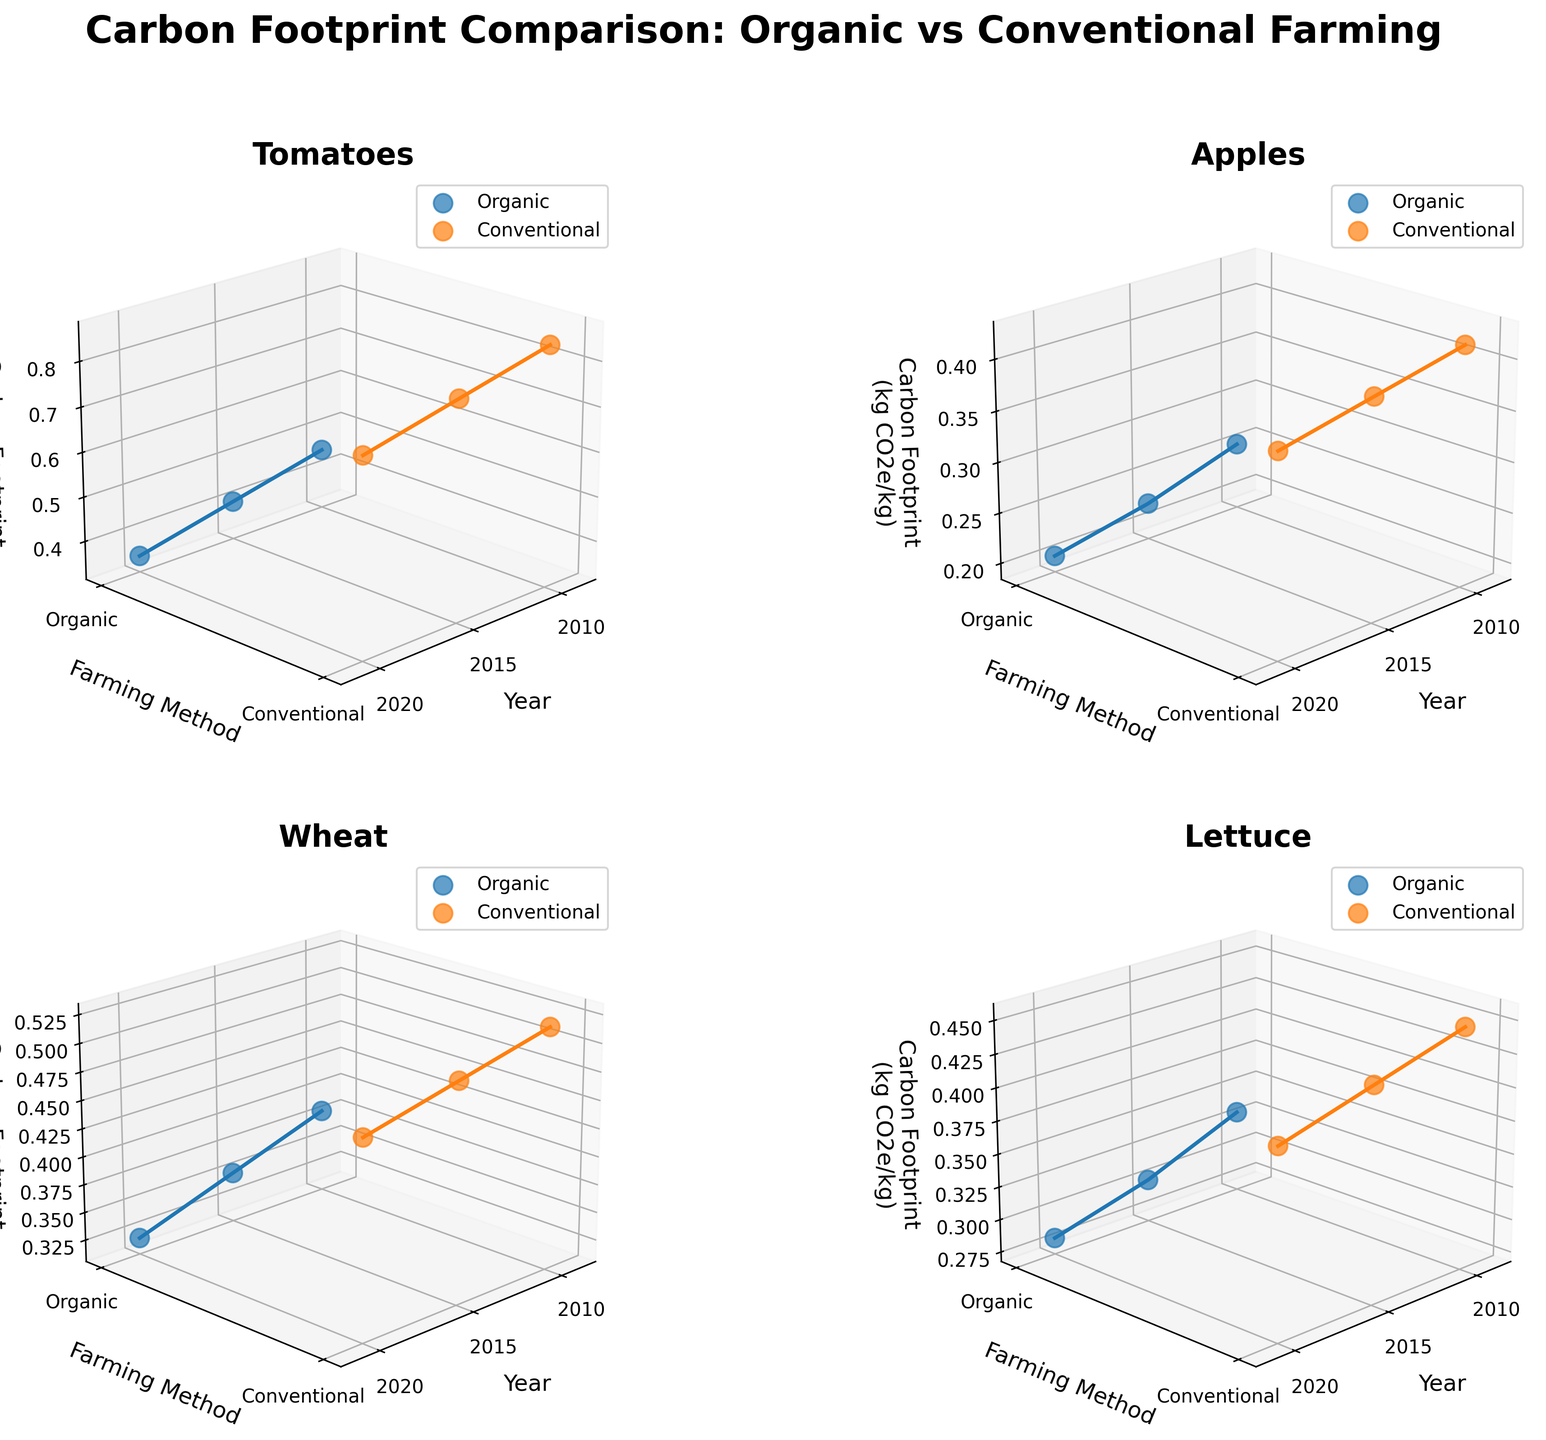What is the title of the figure? The title of the figure is shown at the top of the plot. It's written text within the figure.
Answer: Carbon Footprint Comparison: Organic vs Conventional Farming How many products are compared in the figure? To find the number of products, examine the subplots in the figure. Each subplot corresponds to a different product. Count the subplots to determine the number of products compared.
Answer: 4 Which farming method has a higher carbon footprint for Tomatoes in 2020? Look at the subplot for Tomatoes and compare the height of the points (z-axis value) at the year 2020 for both farming methods (Organic and Conventional).
Answer: Conventional What is the trend for the carbon footprint of Organic Apples from 2010 to 2020? Examine the subplot for Apples and look at the points corresponding to Organic farming from 2010 to 2020. Note the change in the height of these points (z-axis values) over time.
Answer: Decreasing Compare the carbon footprint of Organic and Conventional Wheat in 2010 and 2020. Which year and farming method combination has the lowest carbon footprint? Look at the subplot for Wheat and compare the z-axis values for Organic and Conventional farming methods in both 2010 and 2020. Identify the combination with the smallest value.
Answer: Organic Wheat in 2020 Which farming method has a greater reduction in carbon footprint for Lettuce between 2010 and 2020? Examine the subplot for Lettuce and calculate the difference in z-axis values from 2010 to 2020 for both Organic and Conventional farming methods. Compare these reductions.
Answer: Organic What's the average carbon footprint for Conventional Tomatoes over the years displayed? For the Conventional farming method of Tomatoes, find the z-axis values for each year (2010, 2015, 2020), sum them up, and divide by the number of years. (0.85 + 0.80 + 0.75)/3
Answer: 0.80 How does the carbon footprint of Organic farming for Lettuce compare to Conventional farming in 2015? Look at the subplot for Lettuce and compare the z-axis values for Organic and Conventional farming methods at the year 2015. Determine which is higher or lower.
Answer: Organic is lower Which year had the highest carbon footprint for Conventional farming methods across all products? Examine the z-axis values for Conventional farming methods across all subplots and identify the year with the highest value.
Answer: 2010 How does the trend of the carbon footprint for Conventional farming of Wheat compare to Organic farming of Wheat from 2010 to 2020? Look at the subplot for Wheat and examine the z-axis values for both Conventional and Organic farming from 2010 to 2020. Compare how the footprints change over these years for both methods.
Answer: Both decrease, with Conventional having a slightly smaller reduction 